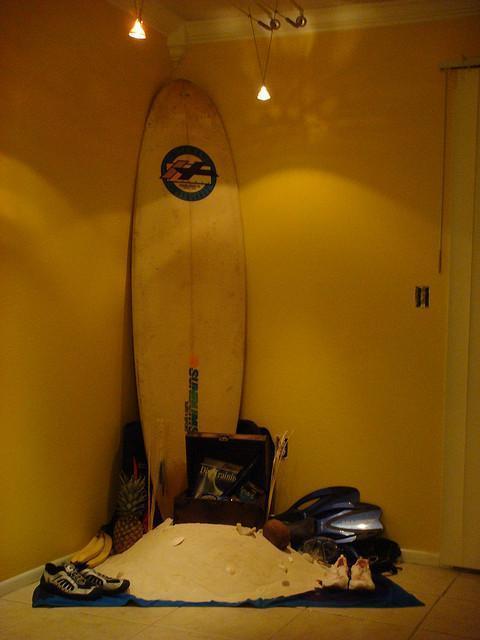How many people have black shirts on?
Give a very brief answer. 0. 